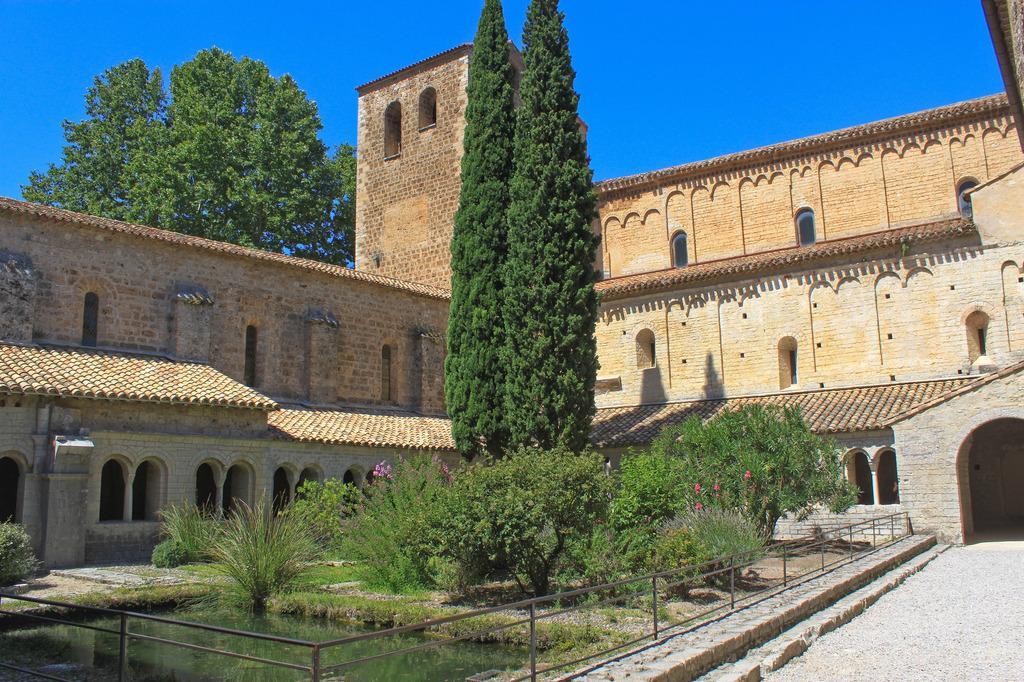In one or two sentences, can you explain what this image depicts? In this image we can see buildings, trees, plants, pond, pavements, railings and sky. 